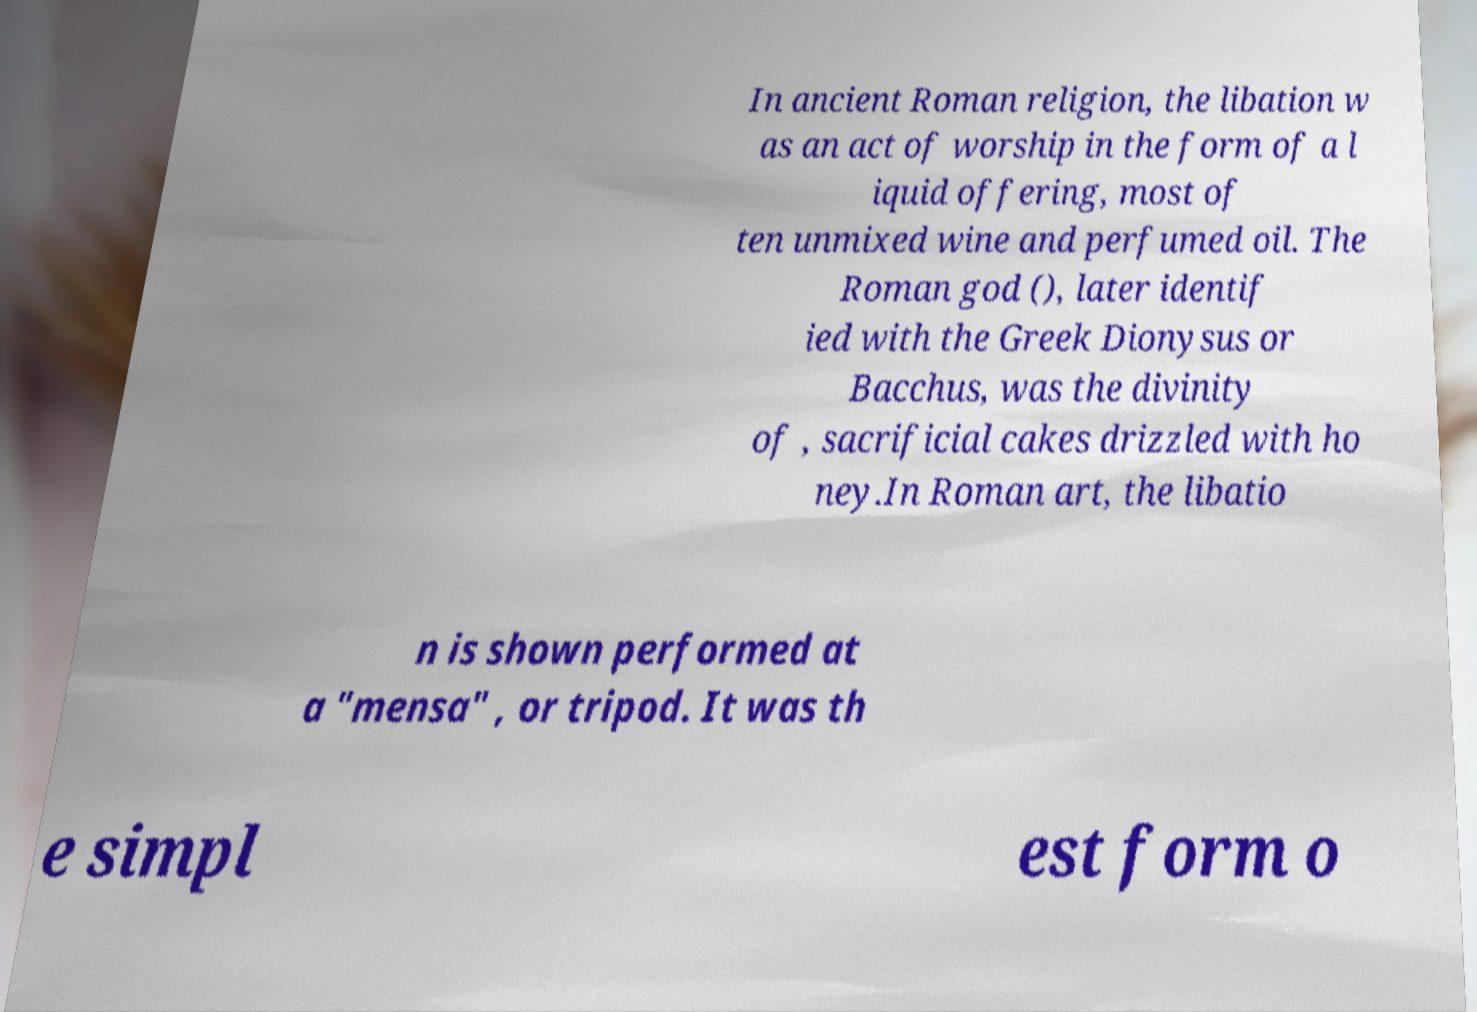Can you accurately transcribe the text from the provided image for me? In ancient Roman religion, the libation w as an act of worship in the form of a l iquid offering, most of ten unmixed wine and perfumed oil. The Roman god (), later identif ied with the Greek Dionysus or Bacchus, was the divinity of , sacrificial cakes drizzled with ho ney.In Roman art, the libatio n is shown performed at a "mensa" , or tripod. It was th e simpl est form o 